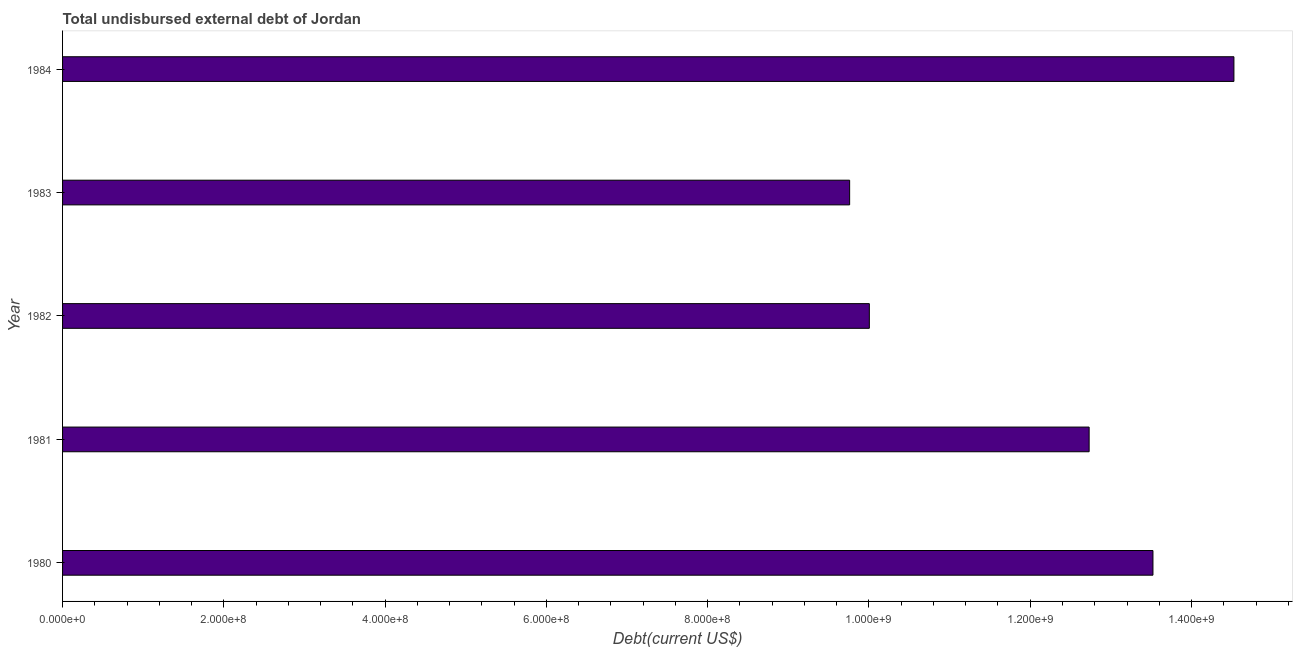Does the graph contain grids?
Give a very brief answer. No. What is the title of the graph?
Keep it short and to the point. Total undisbursed external debt of Jordan. What is the label or title of the X-axis?
Offer a very short reply. Debt(current US$). What is the label or title of the Y-axis?
Keep it short and to the point. Year. What is the total debt in 1980?
Ensure brevity in your answer.  1.35e+09. Across all years, what is the maximum total debt?
Give a very brief answer. 1.45e+09. Across all years, what is the minimum total debt?
Make the answer very short. 9.76e+08. In which year was the total debt maximum?
Offer a very short reply. 1984. In which year was the total debt minimum?
Provide a short and direct response. 1983. What is the sum of the total debt?
Your response must be concise. 6.05e+09. What is the difference between the total debt in 1980 and 1984?
Offer a terse response. -1.00e+08. What is the average total debt per year?
Offer a very short reply. 1.21e+09. What is the median total debt?
Provide a succinct answer. 1.27e+09. In how many years, is the total debt greater than 240000000 US$?
Your answer should be very brief. 5. Do a majority of the years between 1982 and 1983 (inclusive) have total debt greater than 600000000 US$?
Ensure brevity in your answer.  Yes. What is the ratio of the total debt in 1981 to that in 1984?
Offer a terse response. 0.88. Is the total debt in 1982 less than that in 1984?
Keep it short and to the point. Yes. Is the difference between the total debt in 1983 and 1984 greater than the difference between any two years?
Provide a succinct answer. Yes. What is the difference between the highest and the second highest total debt?
Ensure brevity in your answer.  1.00e+08. Is the sum of the total debt in 1980 and 1984 greater than the maximum total debt across all years?
Your response must be concise. Yes. What is the difference between the highest and the lowest total debt?
Give a very brief answer. 4.77e+08. In how many years, is the total debt greater than the average total debt taken over all years?
Your answer should be compact. 3. How many bars are there?
Make the answer very short. 5. Are all the bars in the graph horizontal?
Provide a succinct answer. Yes. What is the Debt(current US$) of 1980?
Provide a succinct answer. 1.35e+09. What is the Debt(current US$) of 1981?
Make the answer very short. 1.27e+09. What is the Debt(current US$) of 1982?
Your answer should be compact. 1.00e+09. What is the Debt(current US$) in 1983?
Give a very brief answer. 9.76e+08. What is the Debt(current US$) of 1984?
Your response must be concise. 1.45e+09. What is the difference between the Debt(current US$) in 1980 and 1981?
Your response must be concise. 7.92e+07. What is the difference between the Debt(current US$) in 1980 and 1982?
Provide a short and direct response. 3.52e+08. What is the difference between the Debt(current US$) in 1980 and 1983?
Provide a short and direct response. 3.76e+08. What is the difference between the Debt(current US$) in 1980 and 1984?
Your answer should be very brief. -1.00e+08. What is the difference between the Debt(current US$) in 1981 and 1982?
Offer a terse response. 2.73e+08. What is the difference between the Debt(current US$) in 1981 and 1983?
Your answer should be very brief. 2.97e+08. What is the difference between the Debt(current US$) in 1981 and 1984?
Provide a short and direct response. -1.80e+08. What is the difference between the Debt(current US$) in 1982 and 1983?
Offer a very short reply. 2.44e+07. What is the difference between the Debt(current US$) in 1982 and 1984?
Provide a succinct answer. -4.52e+08. What is the difference between the Debt(current US$) in 1983 and 1984?
Keep it short and to the point. -4.77e+08. What is the ratio of the Debt(current US$) in 1980 to that in 1981?
Keep it short and to the point. 1.06. What is the ratio of the Debt(current US$) in 1980 to that in 1982?
Your response must be concise. 1.35. What is the ratio of the Debt(current US$) in 1980 to that in 1983?
Provide a short and direct response. 1.39. What is the ratio of the Debt(current US$) in 1981 to that in 1982?
Offer a terse response. 1.27. What is the ratio of the Debt(current US$) in 1981 to that in 1983?
Your answer should be compact. 1.3. What is the ratio of the Debt(current US$) in 1981 to that in 1984?
Offer a very short reply. 0.88. What is the ratio of the Debt(current US$) in 1982 to that in 1983?
Keep it short and to the point. 1.02. What is the ratio of the Debt(current US$) in 1982 to that in 1984?
Offer a terse response. 0.69. What is the ratio of the Debt(current US$) in 1983 to that in 1984?
Give a very brief answer. 0.67. 